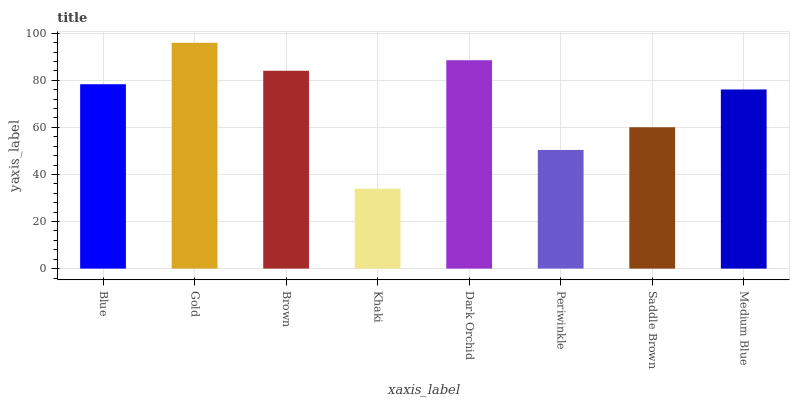Is Khaki the minimum?
Answer yes or no. Yes. Is Gold the maximum?
Answer yes or no. Yes. Is Brown the minimum?
Answer yes or no. No. Is Brown the maximum?
Answer yes or no. No. Is Gold greater than Brown?
Answer yes or no. Yes. Is Brown less than Gold?
Answer yes or no. Yes. Is Brown greater than Gold?
Answer yes or no. No. Is Gold less than Brown?
Answer yes or no. No. Is Blue the high median?
Answer yes or no. Yes. Is Medium Blue the low median?
Answer yes or no. Yes. Is Gold the high median?
Answer yes or no. No. Is Gold the low median?
Answer yes or no. No. 